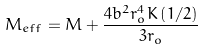<formula> <loc_0><loc_0><loc_500><loc_500>M _ { e f f } = M + \frac { 4 b ^ { 2 } r _ { o } ^ { 4 } K \left ( 1 / 2 \right ) } { 3 r _ { o } }</formula> 